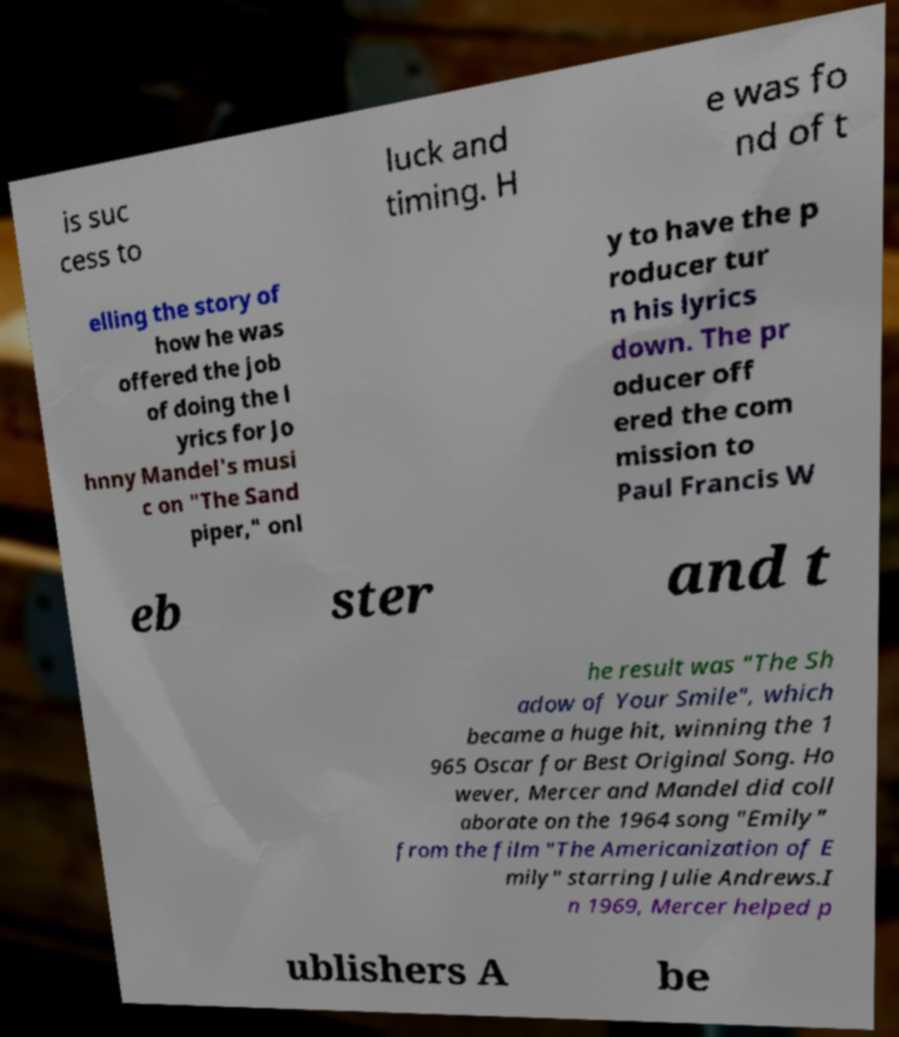Can you read and provide the text displayed in the image?This photo seems to have some interesting text. Can you extract and type it out for me? is suc cess to luck and timing. H e was fo nd of t elling the story of how he was offered the job of doing the l yrics for Jo hnny Mandel's musi c on "The Sand piper," onl y to have the p roducer tur n his lyrics down. The pr oducer off ered the com mission to Paul Francis W eb ster and t he result was "The Sh adow of Your Smile", which became a huge hit, winning the 1 965 Oscar for Best Original Song. Ho wever, Mercer and Mandel did coll aborate on the 1964 song "Emily" from the film "The Americanization of E mily" starring Julie Andrews.I n 1969, Mercer helped p ublishers A be 